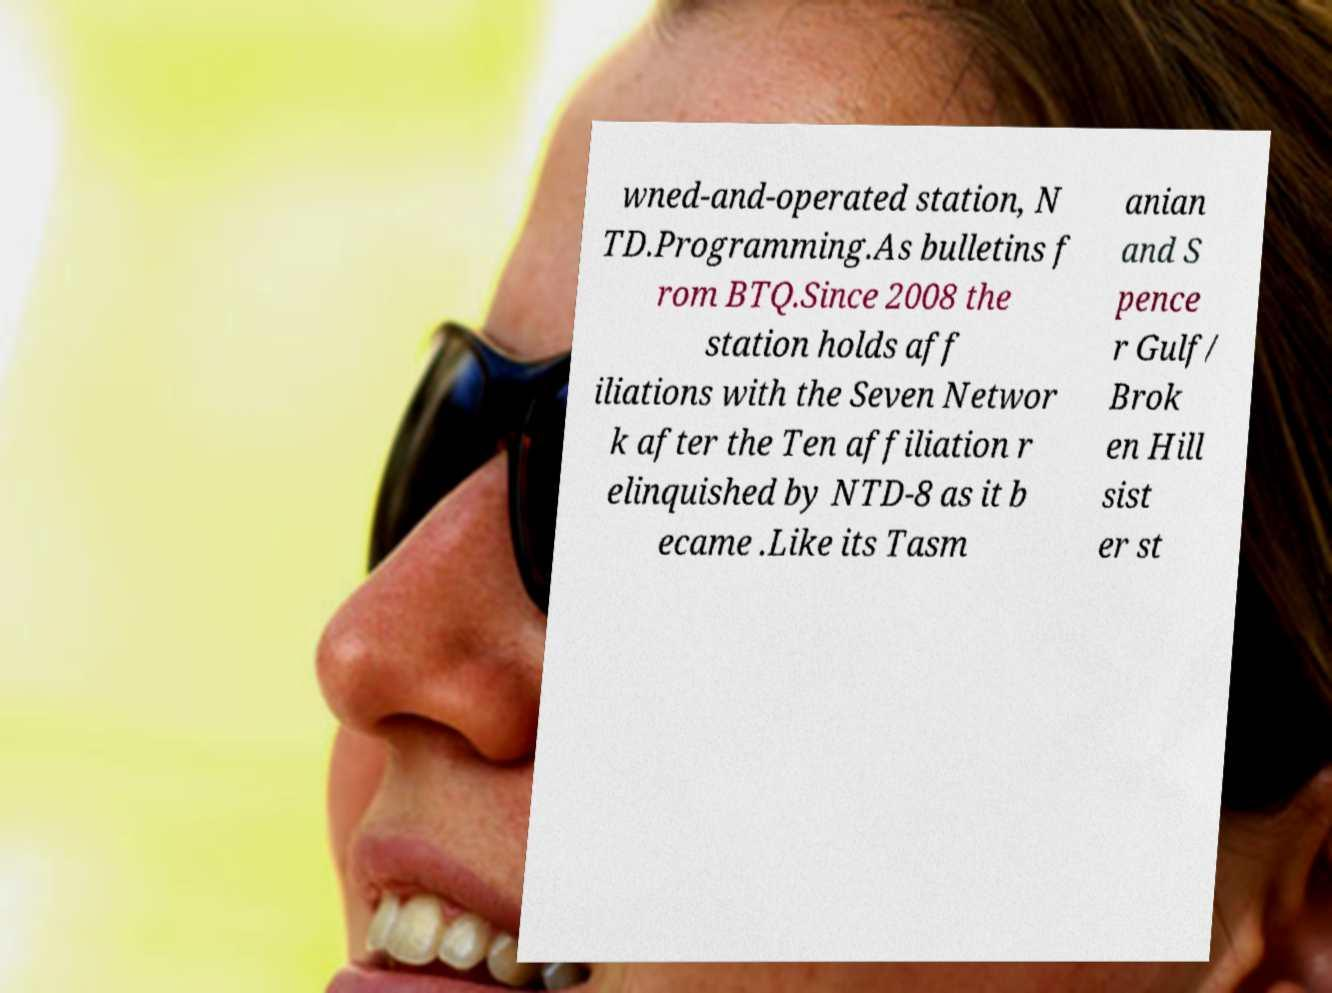Can you accurately transcribe the text from the provided image for me? wned-and-operated station, N TD.Programming.As bulletins f rom BTQ.Since 2008 the station holds aff iliations with the Seven Networ k after the Ten affiliation r elinquished by NTD-8 as it b ecame .Like its Tasm anian and S pence r Gulf/ Brok en Hill sist er st 